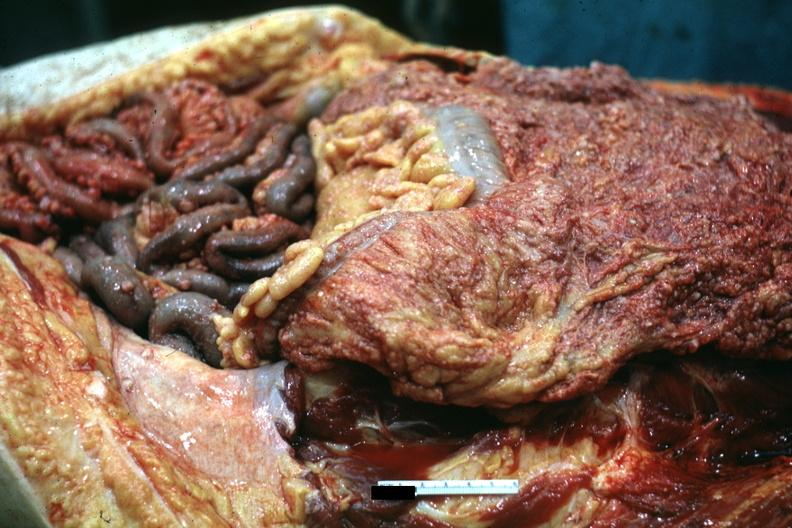what does this image show?
Answer the question using a single word or phrase. Opened abdominal cavity with extensive tumor implants on omentum and bowel 